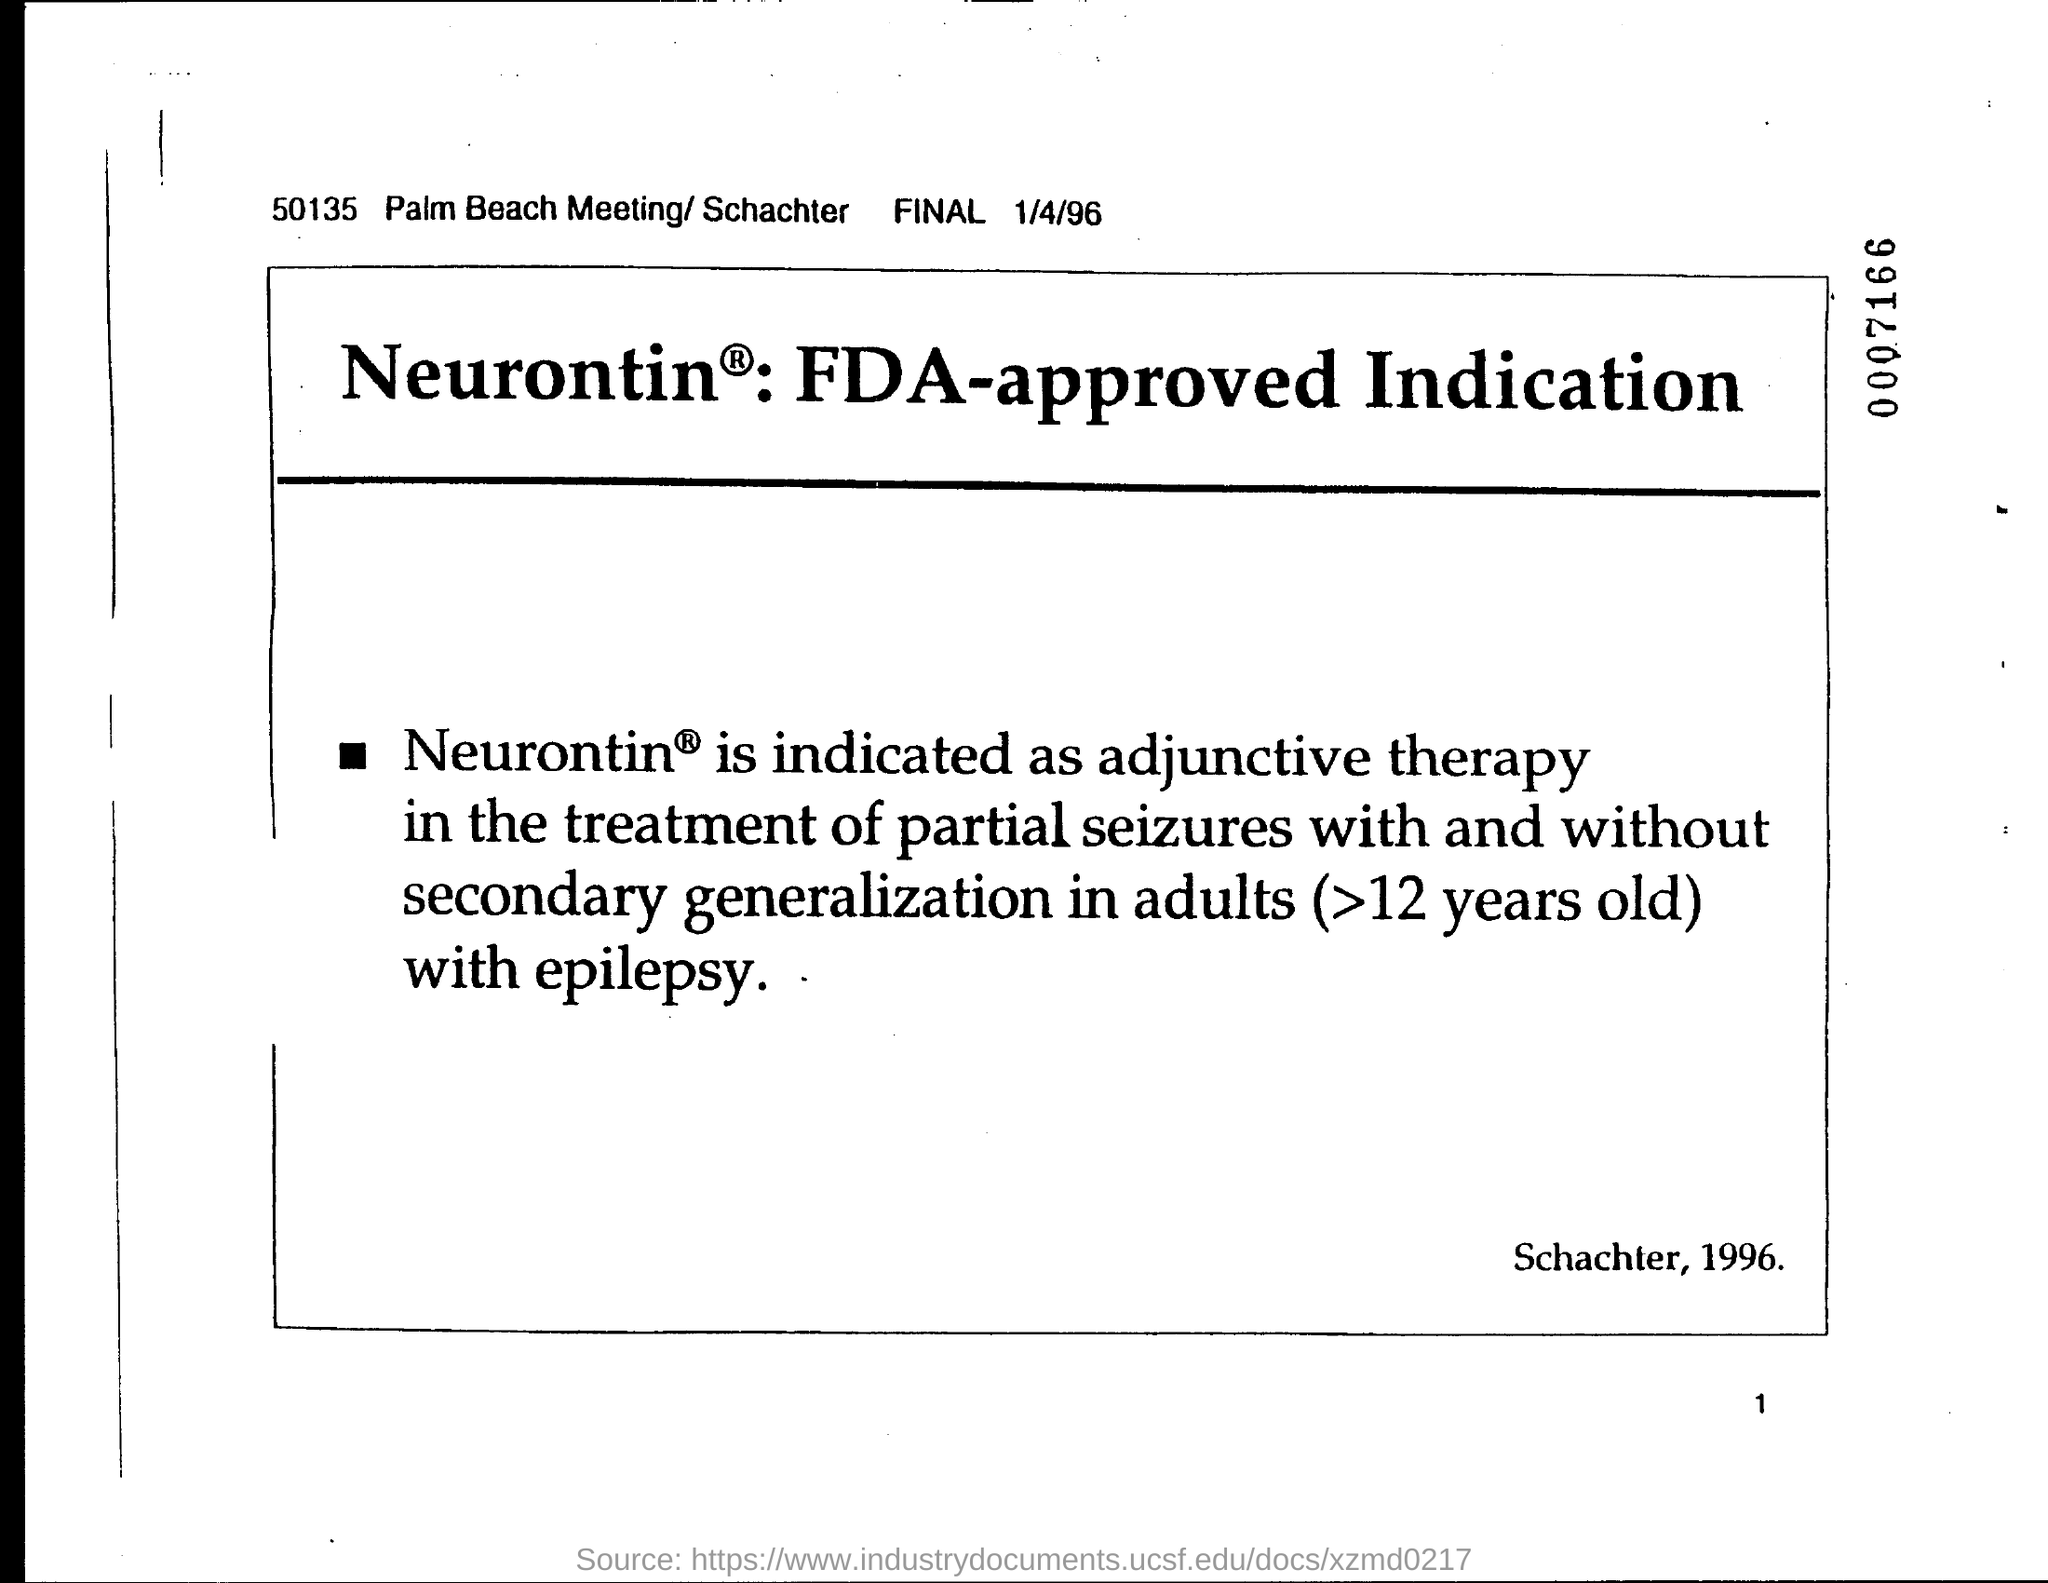What is the date on the document?
Provide a short and direct response. 1/4/96. 